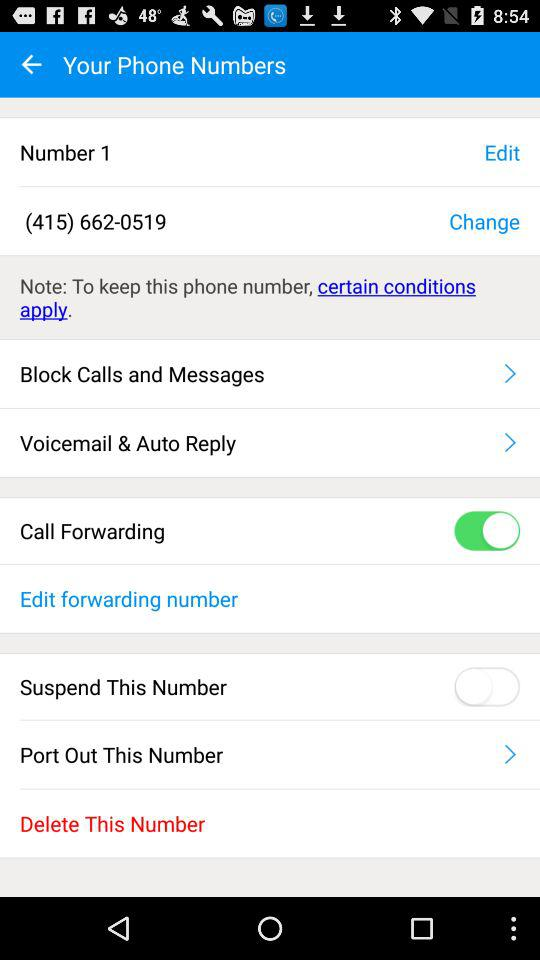What is the status of "Call Forwarding"? The status of "Call Forwarding" is "on". 